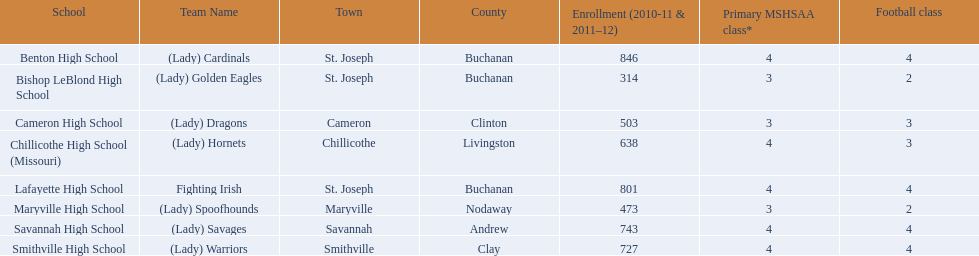Which educational institutions can be found in st. joseph? Benton High School, Bishop LeBlond High School, Lafayette High School. For the academic years 2010-11 and 2011-12, which st. joseph schools had over 800 enrollees? Benton High School, Lafayette High School. What is the name of the st. joseph school with 800 or more enrollments whose team name does not include "lady"? Lafayette High School. 